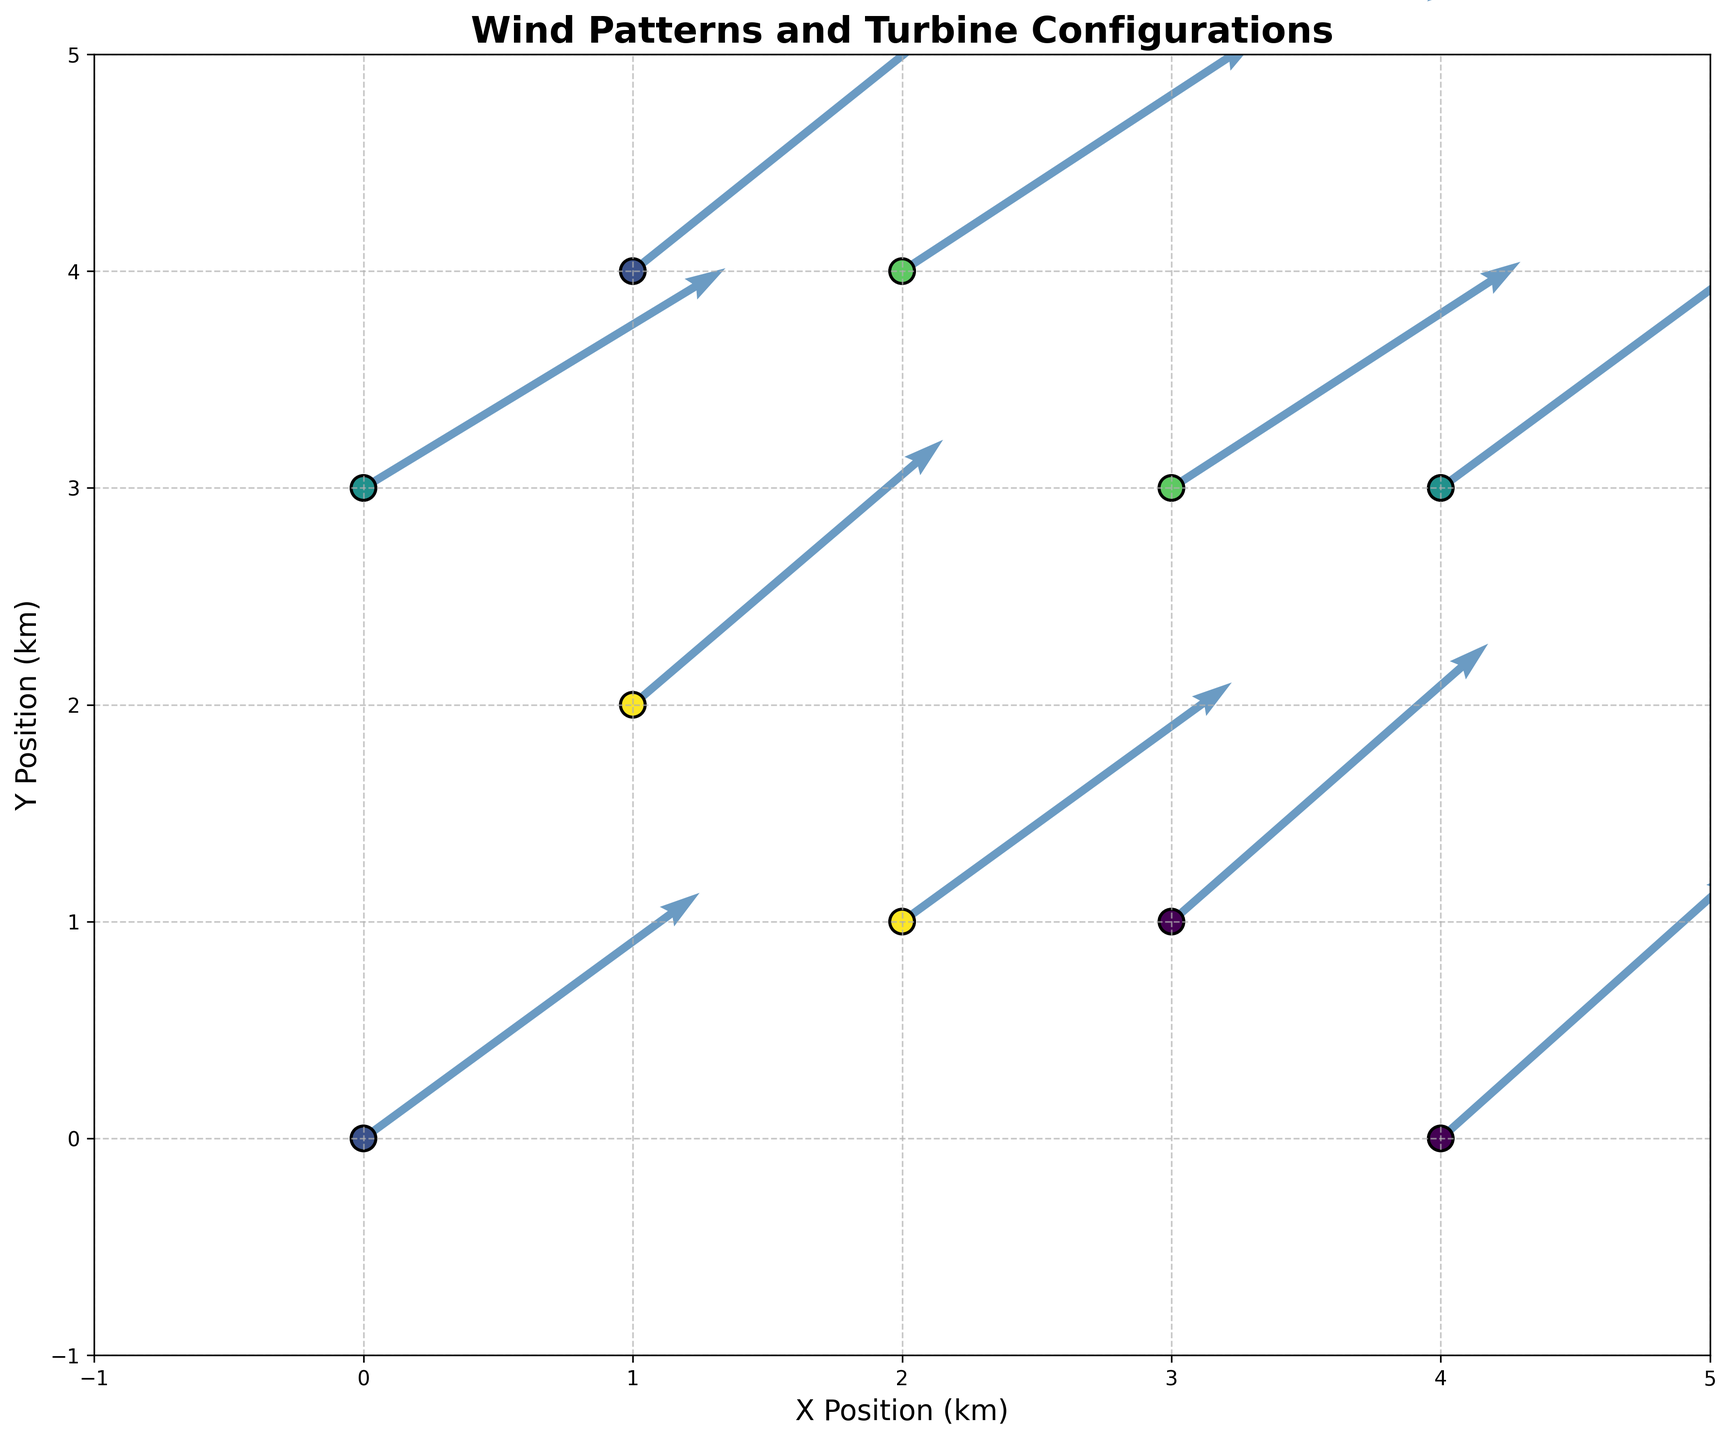What is the main title of the figure? The main title is located at the top of the figure. It is written in a prominent, bold font to indicate the primary subject of the plot.
Answer: Wind Patterns and Turbine Configurations How many different turbine types are shown in the figure? By observing the colors in the legend, each representing a unique turbine type, you can count the distinct categories.
Answer: 5 What is the scale of the wind velocity vectors in the figure? The scale is indicated by the quiver key on the top right portion of the plot. It shows the length of the vector corresponding to a specific velocity magnitude.
Answer: 5 m/s Which turbine type is located at position (0, 3)? By locating the point (0, 3) on the plot and referring to the color indicated in the legend, you can determine the turbine type.
Answer: Gamesa G80 What is the average wind velocity in the x-direction for turbines of type 'Vestas V90'? Locate the points corresponding to 'Vestas V90' using the legend, then average their u-values (4.8 and 5.1). The average is (4.8 + 5.1) / 2 = 4.95.
Answer: 4.95 Which turbine type shows the highest wind velocity in the y-direction? Identify the vectors with the highest v-values by visually inspecting the plot. Compare the corresponding turbine types.
Answer: Enercon E-70 (4.3) How many turbines are positioned in quadrant II (x < 0 and y > 0)? Count the data points that fall in the specified quadrant by inspecting their x and y values on the plot.
Answer: 0 What is the total number of turbines represented in the figure? Count all the data points (scattered points) shown in the plot.
Answer: 10 Compare the wind velocity vectors for 'GE 1.5 MW' and 'Siemens SWT-2.3'. Which turbines have longer vectors on average? Compute the vector magnitudes for u and v for both 'GE 1.5 MW' (√(5.2² + 3.8²) and √(5.0² + 4.0²)) and 'Siemens SWT-2.3' (√(5.5² + 3.6²) and √(5.4² + 3.5²)). Compare averages.
Answer: Siemens SWT-2.3 Are there any turbines located at the same position? If so, which ones? Check if any data points share the same x and y values, indicating overlapping positions.
Answer: No 